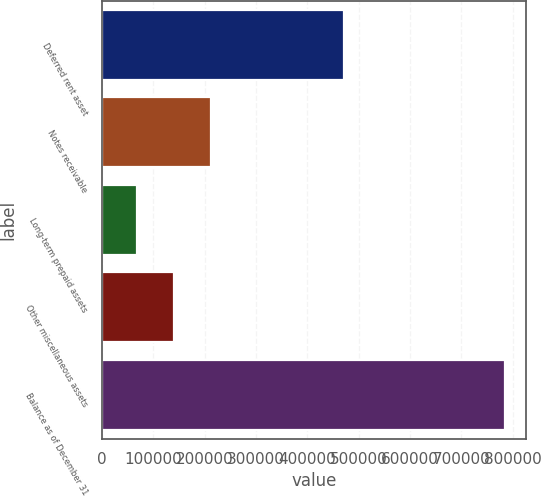Convert chart to OTSL. <chart><loc_0><loc_0><loc_500><loc_500><bar_chart><fcel>Deferred rent asset<fcel>Notes receivable<fcel>Long-term prepaid assets<fcel>Other miscellaneous assets<fcel>Balance as of December 31<nl><fcel>470637<fcel>212487<fcel>69140<fcel>140813<fcel>785874<nl></chart> 